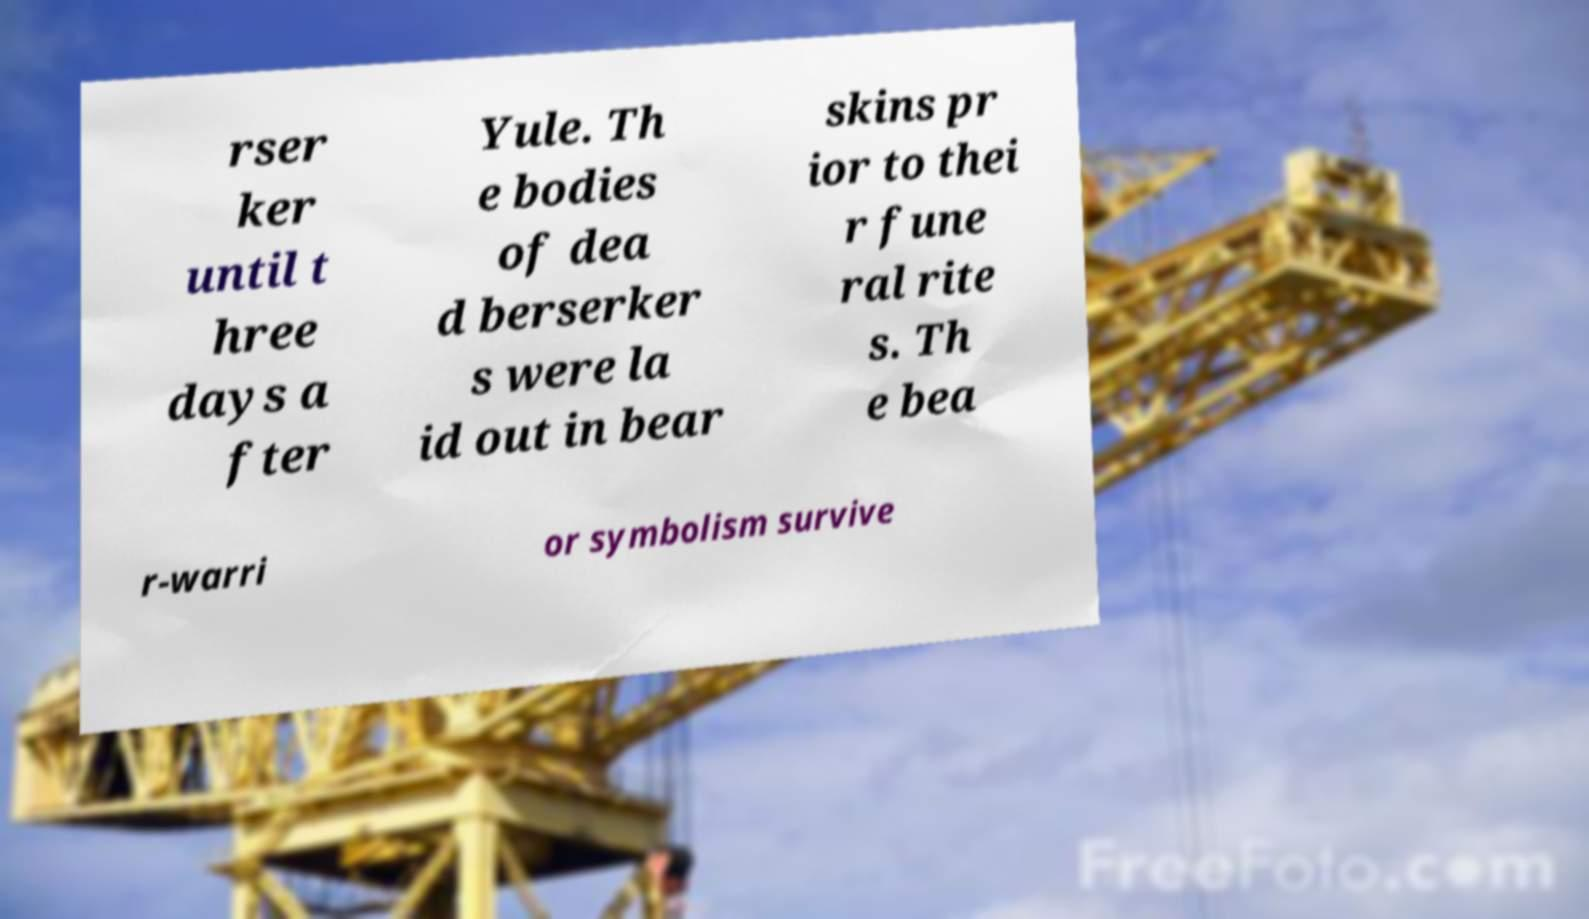There's text embedded in this image that I need extracted. Can you transcribe it verbatim? rser ker until t hree days a fter Yule. Th e bodies of dea d berserker s were la id out in bear skins pr ior to thei r fune ral rite s. Th e bea r-warri or symbolism survive 